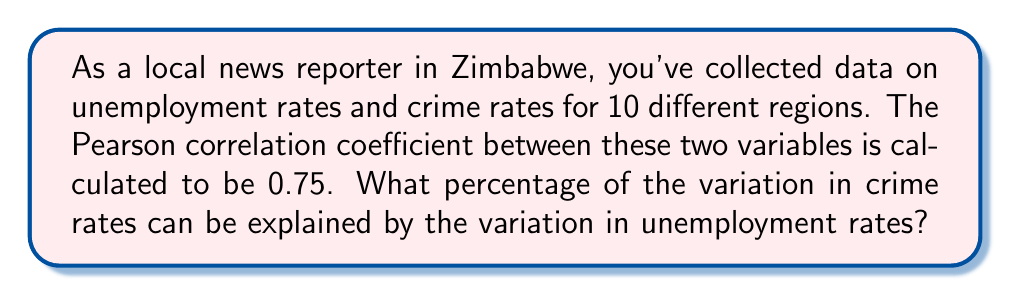What is the answer to this math problem? To solve this problem, we need to understand the concept of the coefficient of determination, which is derived from the Pearson correlation coefficient.

Step 1: Recall that the coefficient of determination (R²) is the square of the Pearson correlation coefficient (r).

$$ R^2 = r^2 $$

Step 2: We are given that the Pearson correlation coefficient (r) is 0.75.

Step 3: Calculate R² by squaring 0.75.

$$ R^2 = (0.75)^2 = 0.5625 $$

Step 4: The coefficient of determination (R²) represents the proportion of variance in the dependent variable (crime rates) that is predictable from the independent variable (unemployment rates).

Step 5: To express this as a percentage, multiply the result by 100.

$$ 0.5625 \times 100 = 56.25\% $$

Therefore, 56.25% of the variation in crime rates can be explained by the variation in unemployment rates across the different regions of Zimbabwe.
Answer: 56.25% 